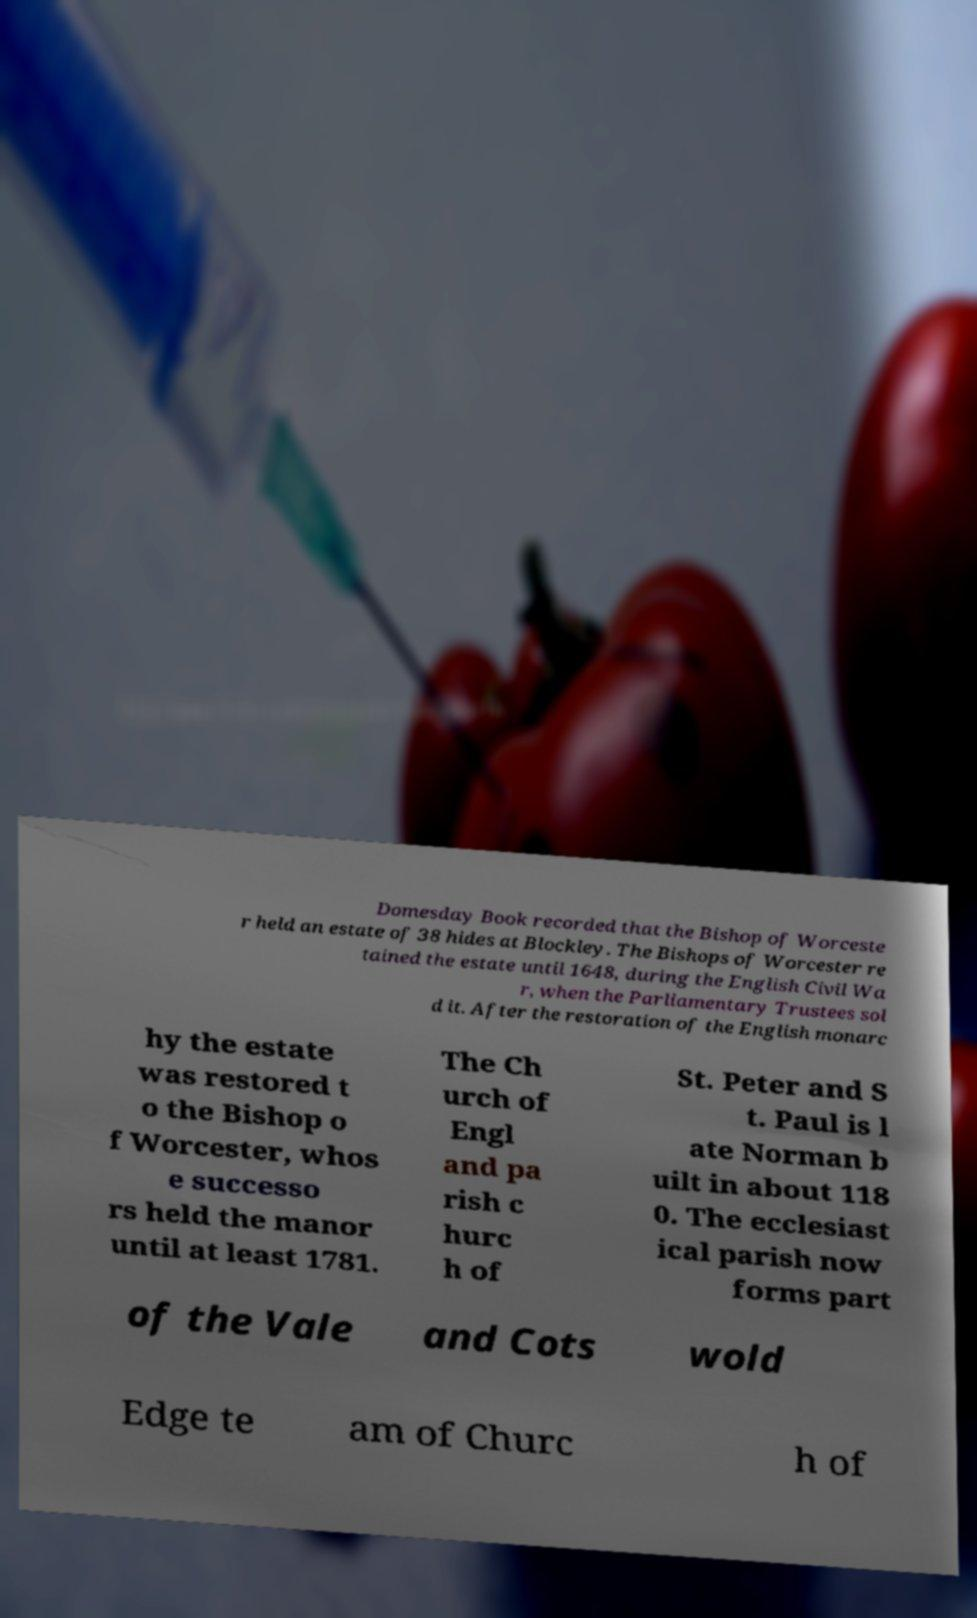There's text embedded in this image that I need extracted. Can you transcribe it verbatim? Domesday Book recorded that the Bishop of Worceste r held an estate of 38 hides at Blockley. The Bishops of Worcester re tained the estate until 1648, during the English Civil Wa r, when the Parliamentary Trustees sol d it. After the restoration of the English monarc hy the estate was restored t o the Bishop o f Worcester, whos e successo rs held the manor until at least 1781. The Ch urch of Engl and pa rish c hurc h of St. Peter and S t. Paul is l ate Norman b uilt in about 118 0. The ecclesiast ical parish now forms part of the Vale and Cots wold Edge te am of Churc h of 